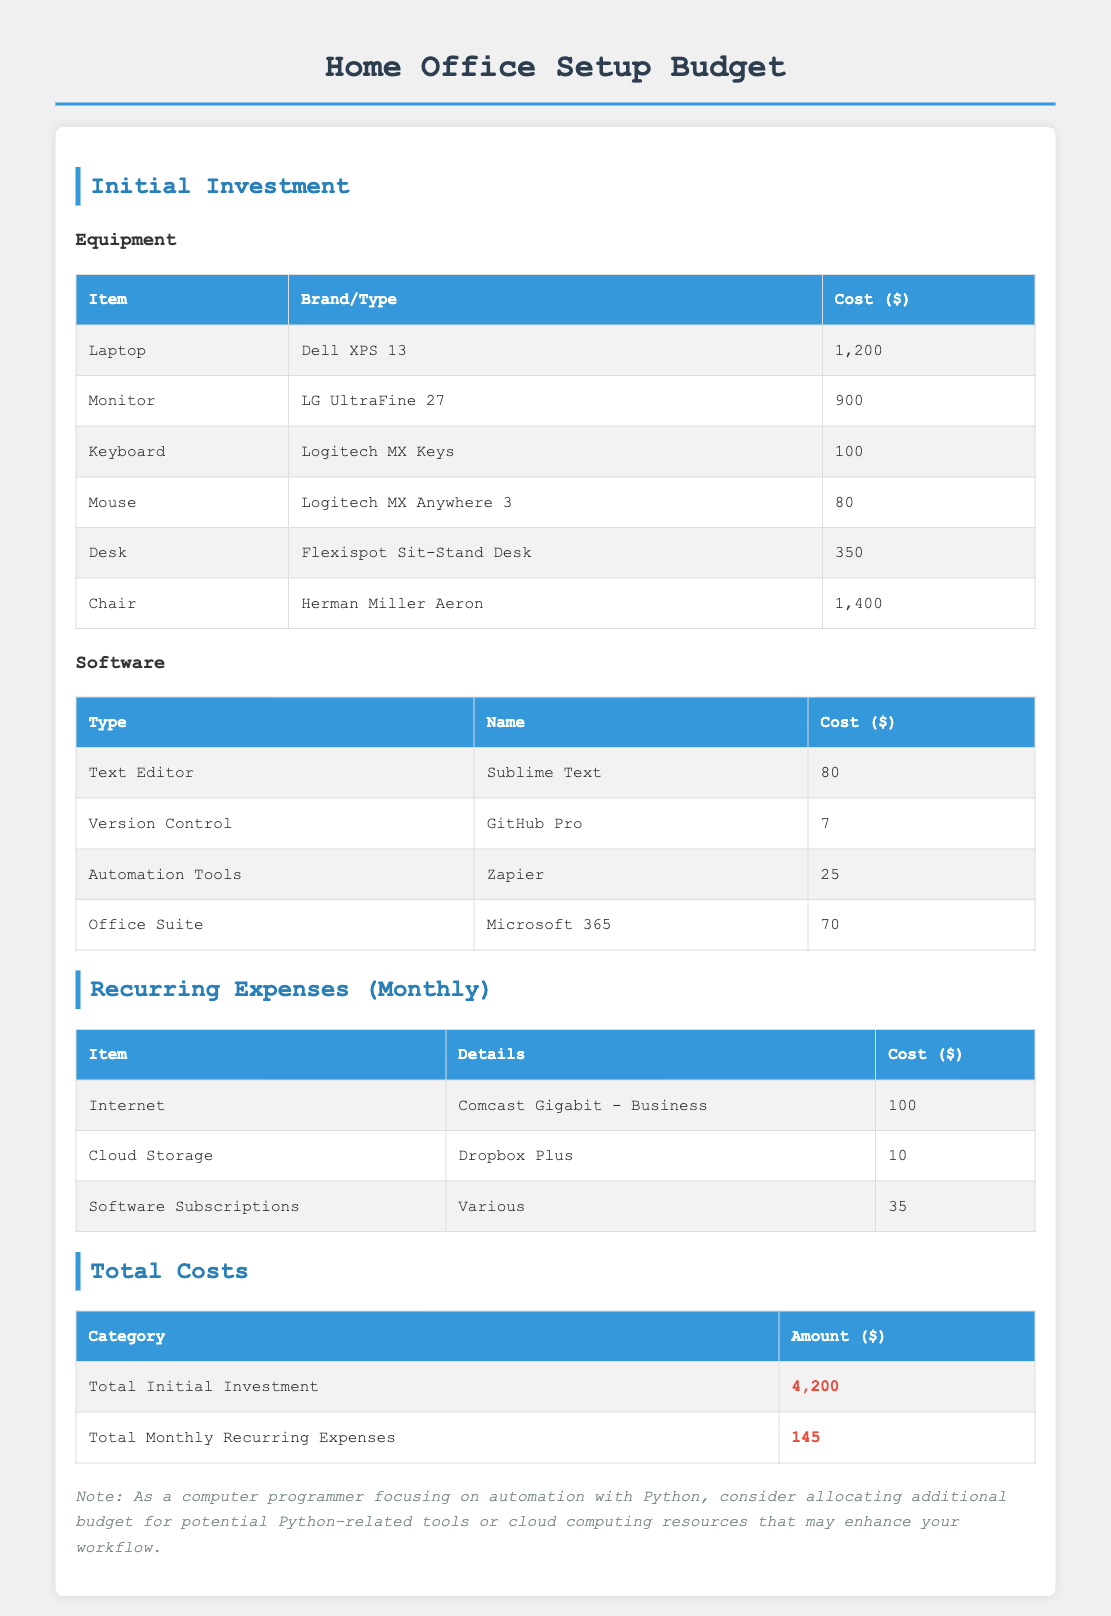What is the total initial investment? The total initial investment is found in the Total Costs section, and it includes all the equipment and software costs.
Answer: 4,200 How much does the Dell XPS 13 cost? The cost of the Dell XPS 13 is listed in the Equipment table under Initial Investment.
Answer: 1,200 What software is used for version control? The software used for version control is mentioned in the Software section of Initial Investment.
Answer: GitHub Pro What is the monthly cost for Internet? The cost for Internet is detailed in the Recurring Expenses section, listing the monthly expenses for services.
Answer: 100 How many items are listed under the Equipment category? The Equipment category includes multiple items, and the number can be counted from the table in the Initial Investment section.
Answer: 6 What is the total monthly recurring expense? The total monthly recurring expense can be found at the bottom of the Total Costs section.
Answer: 145 What is the brand of the keyboard? The brand of the keyboard is specified in the Equipment section under Initial Investment.
Answer: Logitech What type of desk is mentioned in the document? The type of desk is specified in the Equipment section under Initial Investment.
Answer: Flexispot Sit-Stand Desk What additional budget considerations are mentioned in the comment? The comment suggests considering additional budget allocations for specific tools related to a computer programming focus, as noted in the document.
Answer: Python-related tools or cloud computing resources 